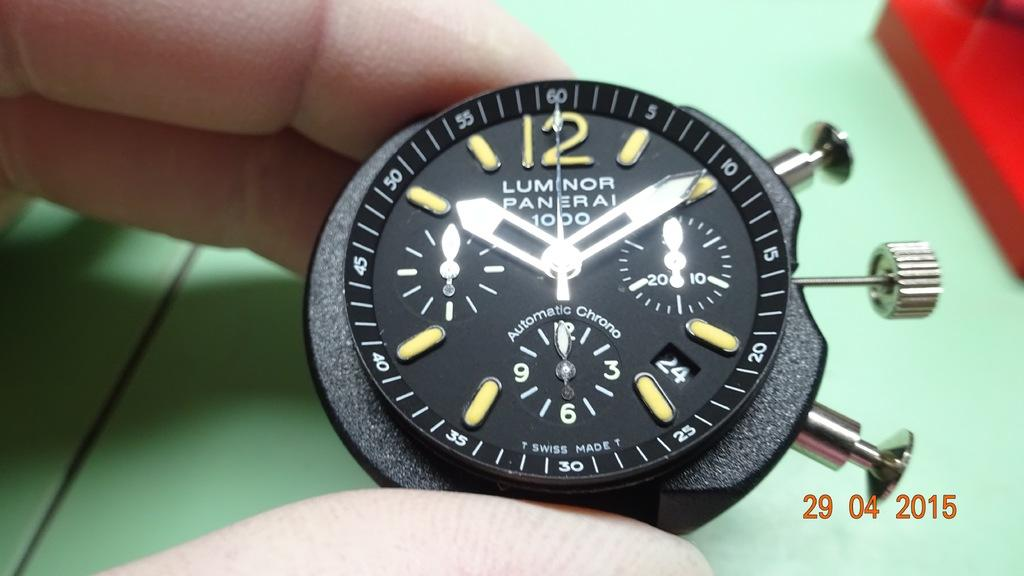<image>
Describe the image concisely. Luminor Paneral 1000 type watch that says its 10:09 and dated 29 04 2015. 